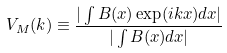Convert formula to latex. <formula><loc_0><loc_0><loc_500><loc_500>V _ { M } ( k ) \equiv \frac { | \int B ( x ) \exp ( i k x ) d x | } { | \int B ( x ) d x | }</formula> 